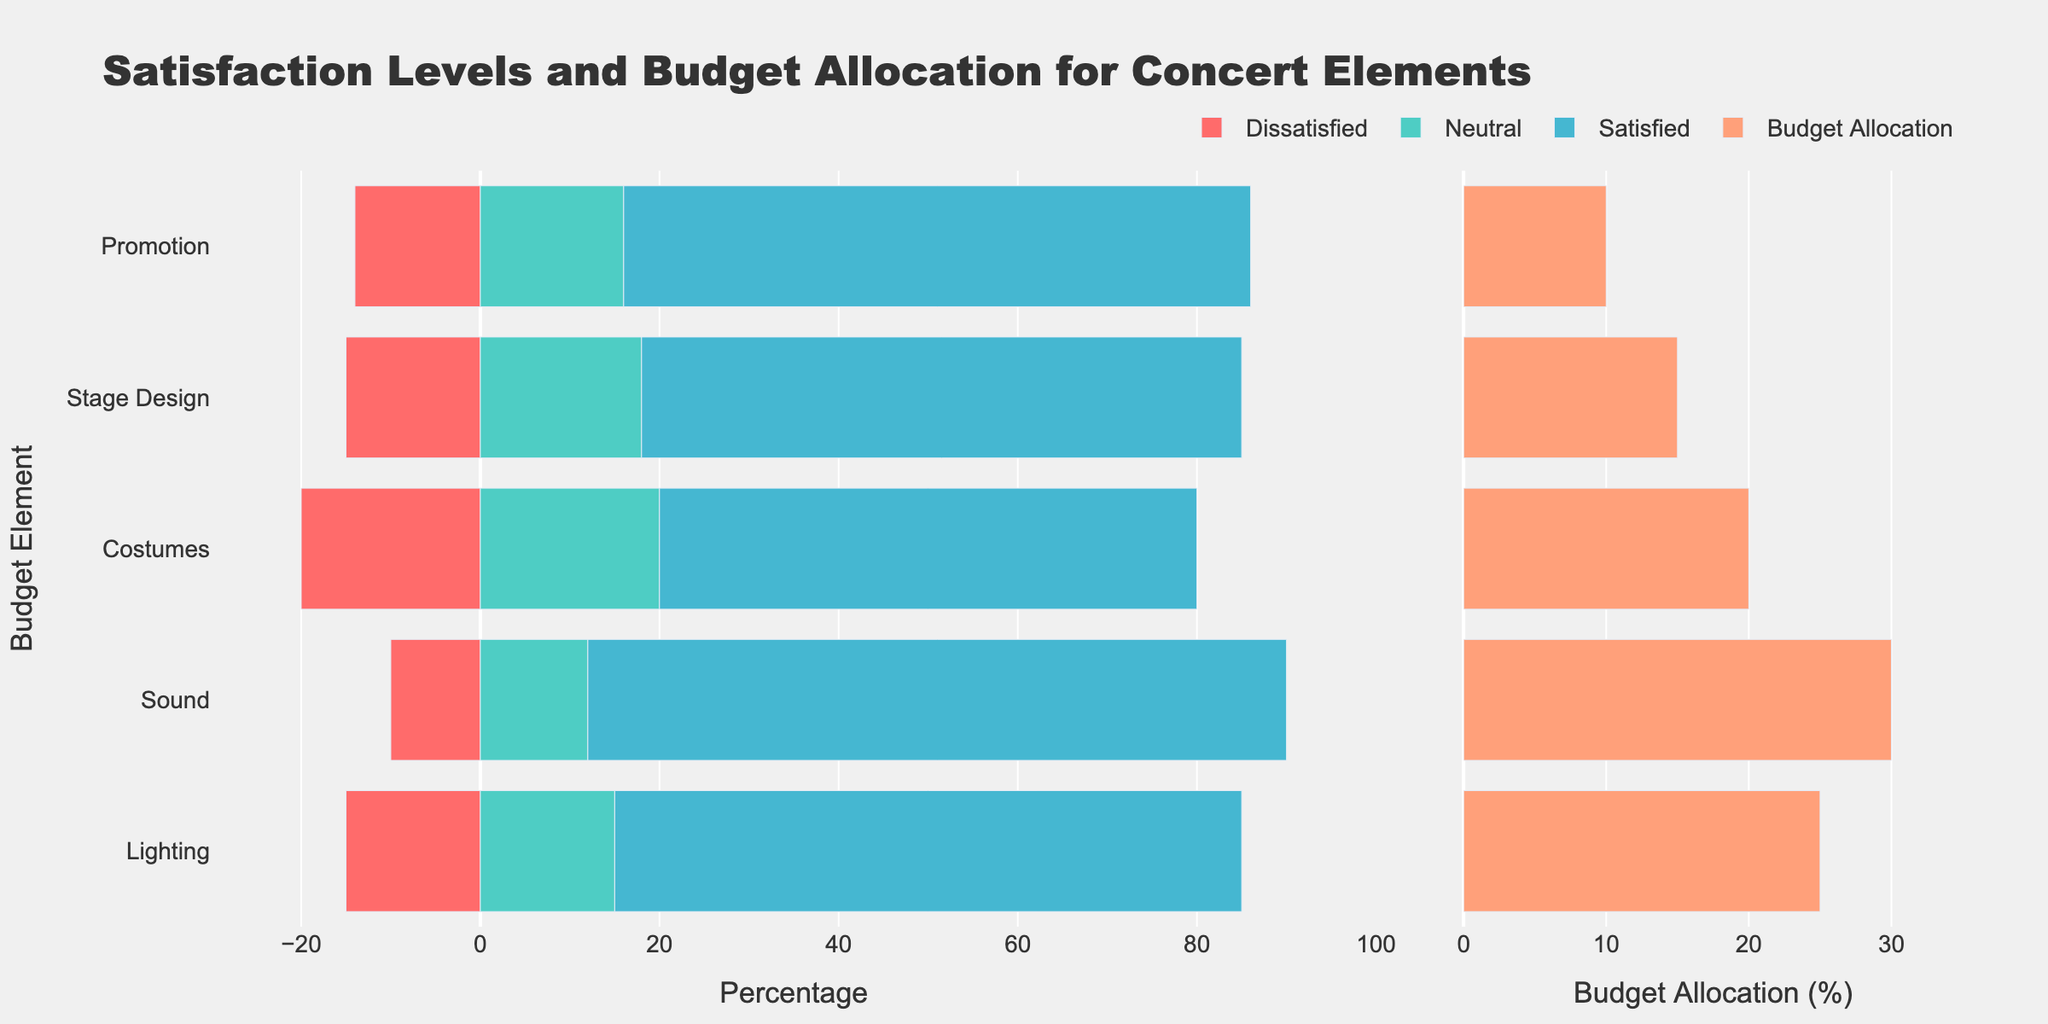Which concert element has the highest percentage of positive satisfaction? Positive satisfaction can be found by summing the "Satisfied" and "Strongly Satisfied" percentages. Sound has 50% + 28% = 78%, which is the highest.
Answer: Sound How much higher is the budget allocation for Sound compared to Promotion? The budget allocation for Sound is 30%, and for Promotion, it's 10%. The difference is 30% - 10%.
Answer: 20% For the Lighting element, what is the combined percentage of neutral and dissatisfied responses? The combined percentage for "Neutral" and "Dissatisfied" in Lighting is 15% + 10% = 25%.
Answer: 25% Which element has the highest percentage of dissatisfaction (combining "Strongly Dissatisfied" and "Dissatisfied")? Dissatisfaction can be found by summing "Strongly Dissatisfied" and "Dissatisfied" for each element. Costumes have 8% + 12% = 20%, which is the highest.
Answer: Costumes What is the average budget allocation across all elements? To calculate the average, add all budget allocations and divide by the number of elements. (25% + 30% + 20% + 15% + 10%) / 5 = 100% / 5 = 20%.
Answer: 20% Which element has the lowest percentage of neutral satisfaction? The percentage of neutral satisfaction is shown directly on the chart. Stage Design has the lowest at 18%.
Answer: Stage Design Compare the number of people strongly dissatisfied with Lighting vs Sound. The chart shows Lighting has 5% and Sound has 3% strongly dissatisfied. 5% is greater than 3%.
Answer: Lighting Which elements have a higher budget allocation than Lighting? Lighting's budget allocation is 25%. Elements with higher allocations are Sound (30%) and none others exceed Lighting's percentage.
Answer: Sound What is the range of budget allocations across all elements? The range is calculated by subtracting the smallest budget allocation from the largest. The minimum allocation is for Promotion (10%) and the maximum is for Sound (30%). 30% - 10% = 20%.
Answer: 20% How does the satisfaction for Stage Design compare to Costumes for positive responses? Stage Design has 40% + 27% = 67% positive responses, and Costumes have 35% + 25% = 60%. Stage Design has a higher percentage of positive responses.
Answer: Stage Design 